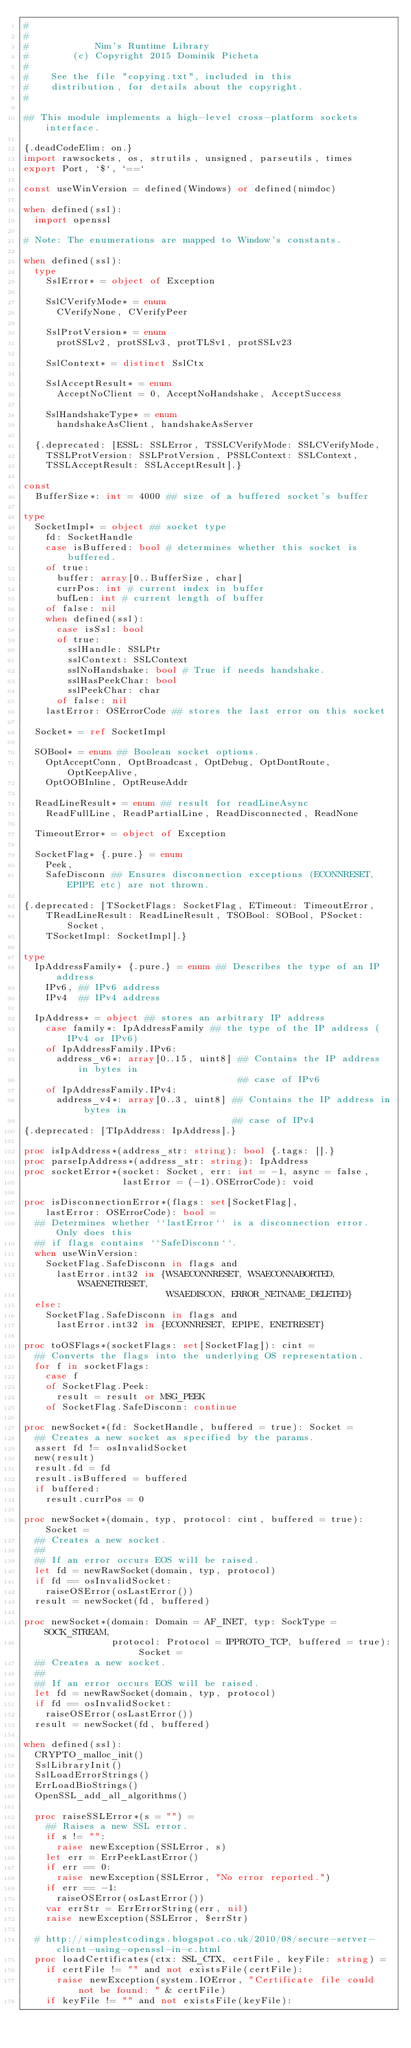<code> <loc_0><loc_0><loc_500><loc_500><_Nim_>#
#
#            Nim's Runtime Library
#        (c) Copyright 2015 Dominik Picheta
#
#    See the file "copying.txt", included in this
#    distribution, for details about the copyright.
#

## This module implements a high-level cross-platform sockets interface.

{.deadCodeElim: on.}
import rawsockets, os, strutils, unsigned, parseutils, times
export Port, `$`, `==`

const useWinVersion = defined(Windows) or defined(nimdoc)

when defined(ssl):
  import openssl

# Note: The enumerations are mapped to Window's constants.

when defined(ssl):
  type
    SslError* = object of Exception

    SslCVerifyMode* = enum
      CVerifyNone, CVerifyPeer

    SslProtVersion* = enum
      protSSLv2, protSSLv3, protTLSv1, protSSLv23

    SslContext* = distinct SslCtx

    SslAcceptResult* = enum
      AcceptNoClient = 0, AcceptNoHandshake, AcceptSuccess

    SslHandshakeType* = enum
      handshakeAsClient, handshakeAsServer

  {.deprecated: [ESSL: SSLError, TSSLCVerifyMode: SSLCVerifyMode,
    TSSLProtVersion: SSLProtVersion, PSSLContext: SSLContext,
    TSSLAcceptResult: SSLAcceptResult].}

const
  BufferSize*: int = 4000 ## size of a buffered socket's buffer

type
  SocketImpl* = object ## socket type
    fd: SocketHandle
    case isBuffered: bool # determines whether this socket is buffered.
    of true:
      buffer: array[0..BufferSize, char]
      currPos: int # current index in buffer
      bufLen: int # current length of buffer
    of false: nil
    when defined(ssl):
      case isSsl: bool
      of true:
        sslHandle: SSLPtr
        sslContext: SSLContext
        sslNoHandshake: bool # True if needs handshake.
        sslHasPeekChar: bool
        sslPeekChar: char
      of false: nil
    lastError: OSErrorCode ## stores the last error on this socket

  Socket* = ref SocketImpl

  SOBool* = enum ## Boolean socket options.
    OptAcceptConn, OptBroadcast, OptDebug, OptDontRoute, OptKeepAlive,
    OptOOBInline, OptReuseAddr

  ReadLineResult* = enum ## result for readLineAsync
    ReadFullLine, ReadPartialLine, ReadDisconnected, ReadNone

  TimeoutError* = object of Exception

  SocketFlag* {.pure.} = enum
    Peek,
    SafeDisconn ## Ensures disconnection exceptions (ECONNRESET, EPIPE etc) are not thrown.

{.deprecated: [TSocketFlags: SocketFlag, ETimeout: TimeoutError,
    TReadLineResult: ReadLineResult, TSOBool: SOBool, PSocket: Socket,
    TSocketImpl: SocketImpl].}

type
  IpAddressFamily* {.pure.} = enum ## Describes the type of an IP address
    IPv6, ## IPv6 address
    IPv4  ## IPv4 address

  IpAddress* = object ## stores an arbitrary IP address
    case family*: IpAddressFamily ## the type of the IP address (IPv4 or IPv6)
    of IpAddressFamily.IPv6:
      address_v6*: array[0..15, uint8] ## Contains the IP address in bytes in
                                       ## case of IPv6
    of IpAddressFamily.IPv4:
      address_v4*: array[0..3, uint8] ## Contains the IP address in bytes in
                                      ## case of IPv4
{.deprecated: [TIpAddress: IpAddress].}

proc isIpAddress*(address_str: string): bool {.tags: [].}
proc parseIpAddress*(address_str: string): IpAddress
proc socketError*(socket: Socket, err: int = -1, async = false,
                  lastError = (-1).OSErrorCode): void

proc isDisconnectionError*(flags: set[SocketFlag],
    lastError: OSErrorCode): bool =
  ## Determines whether ``lastError`` is a disconnection error. Only does this
  ## if flags contains ``SafeDisconn``.
  when useWinVersion:
    SocketFlag.SafeDisconn in flags and
      lastError.int32 in {WSAECONNRESET, WSAECONNABORTED, WSAENETRESET,
                          WSAEDISCON, ERROR_NETNAME_DELETED}
  else:
    SocketFlag.SafeDisconn in flags and
      lastError.int32 in {ECONNRESET, EPIPE, ENETRESET}

proc toOSFlags*(socketFlags: set[SocketFlag]): cint =
  ## Converts the flags into the underlying OS representation.
  for f in socketFlags:
    case f
    of SocketFlag.Peek:
      result = result or MSG_PEEK
    of SocketFlag.SafeDisconn: continue

proc newSocket*(fd: SocketHandle, buffered = true): Socket =
  ## Creates a new socket as specified by the params.
  assert fd != osInvalidSocket
  new(result)
  result.fd = fd
  result.isBuffered = buffered
  if buffered:
    result.currPos = 0

proc newSocket*(domain, typ, protocol: cint, buffered = true): Socket =
  ## Creates a new socket.
  ##
  ## If an error occurs EOS will be raised.
  let fd = newRawSocket(domain, typ, protocol)
  if fd == osInvalidSocket:
    raiseOSError(osLastError())
  result = newSocket(fd, buffered)

proc newSocket*(domain: Domain = AF_INET, typ: SockType = SOCK_STREAM,
                protocol: Protocol = IPPROTO_TCP, buffered = true): Socket =
  ## Creates a new socket.
  ##
  ## If an error occurs EOS will be raised.
  let fd = newRawSocket(domain, typ, protocol)
  if fd == osInvalidSocket:
    raiseOSError(osLastError())
  result = newSocket(fd, buffered)

when defined(ssl):
  CRYPTO_malloc_init()
  SslLibraryInit()
  SslLoadErrorStrings()
  ErrLoadBioStrings()
  OpenSSL_add_all_algorithms()

  proc raiseSSLError*(s = "") =
    ## Raises a new SSL error.
    if s != "":
      raise newException(SSLError, s)
    let err = ErrPeekLastError()
    if err == 0:
      raise newException(SSLError, "No error reported.")
    if err == -1:
      raiseOSError(osLastError())
    var errStr = ErrErrorString(err, nil)
    raise newException(SSLError, $errStr)

  # http://simplestcodings.blogspot.co.uk/2010/08/secure-server-client-using-openssl-in-c.html
  proc loadCertificates(ctx: SSL_CTX, certFile, keyFile: string) =
    if certFile != "" and not existsFile(certFile):
      raise newException(system.IOError, "Certificate file could not be found: " & certFile)
    if keyFile != "" and not existsFile(keyFile):</code> 